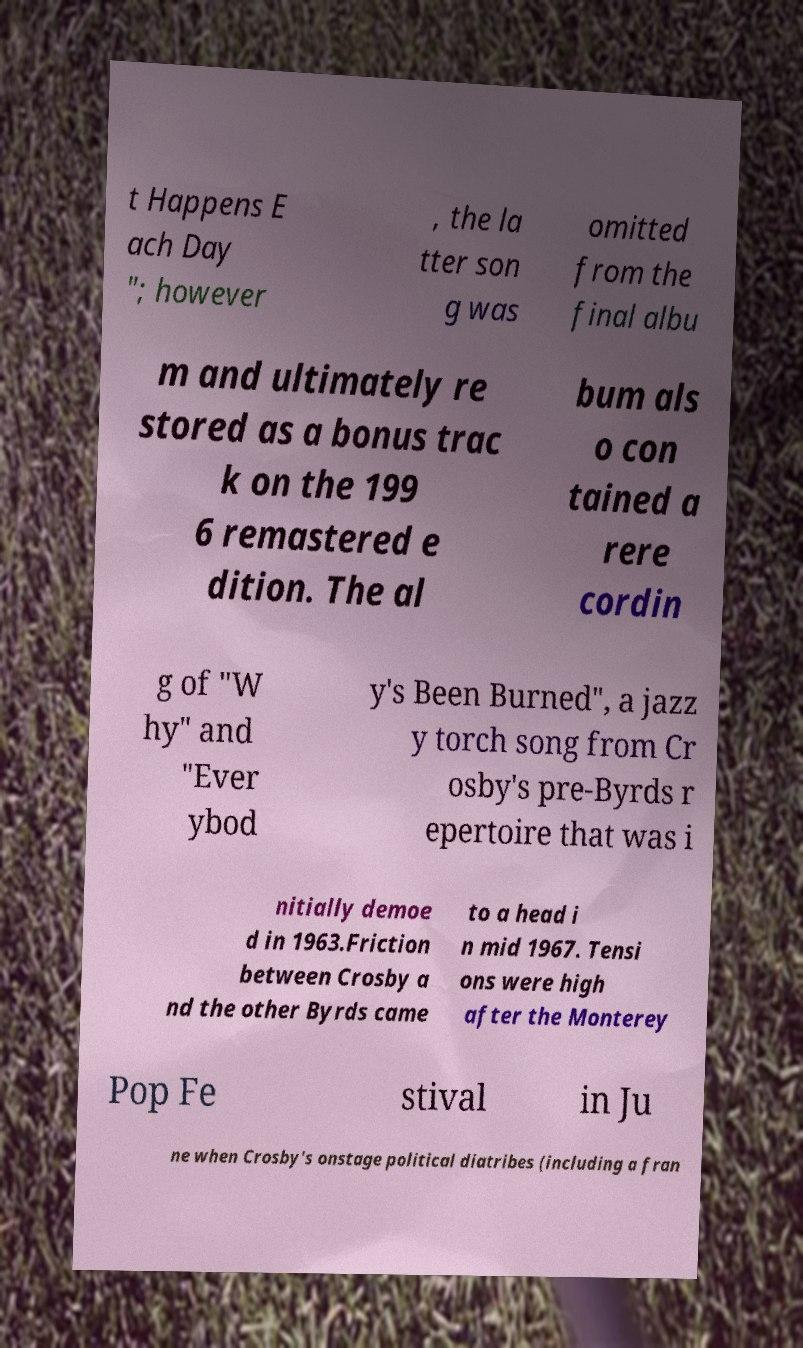Could you assist in decoding the text presented in this image and type it out clearly? t Happens E ach Day "; however , the la tter son g was omitted from the final albu m and ultimately re stored as a bonus trac k on the 199 6 remastered e dition. The al bum als o con tained a rere cordin g of "W hy" and "Ever ybod y's Been Burned", a jazz y torch song from Cr osby's pre-Byrds r epertoire that was i nitially demoe d in 1963.Friction between Crosby a nd the other Byrds came to a head i n mid 1967. Tensi ons were high after the Monterey Pop Fe stival in Ju ne when Crosby's onstage political diatribes (including a fran 